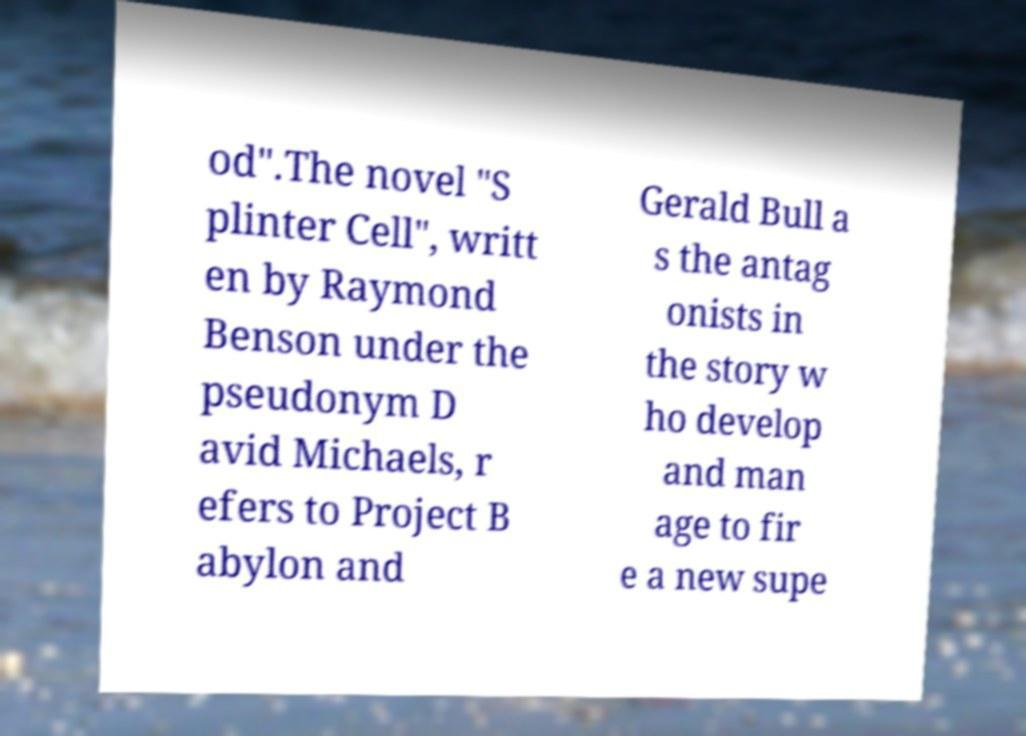I need the written content from this picture converted into text. Can you do that? od".The novel "S plinter Cell", writt en by Raymond Benson under the pseudonym D avid Michaels, r efers to Project B abylon and Gerald Bull a s the antag onists in the story w ho develop and man age to fir e a new supe 